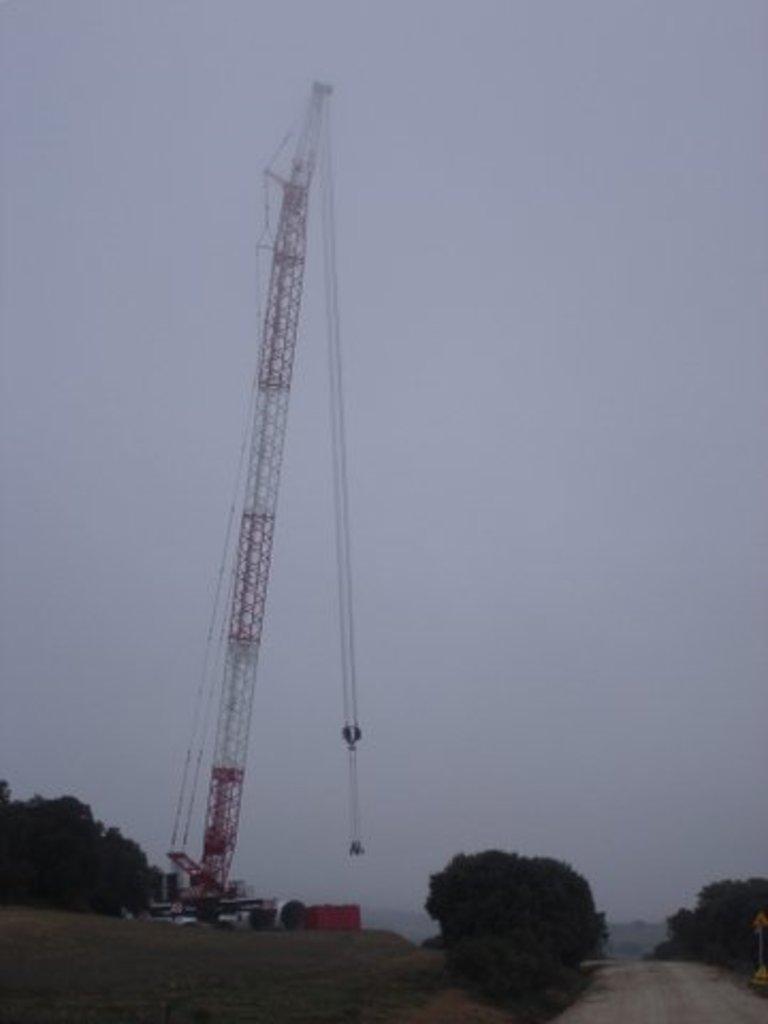In one or two sentences, can you explain what this image depicts? In this picture we can see vehicles,trees and we can see sky in the background. 